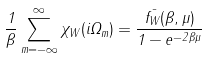Convert formula to latex. <formula><loc_0><loc_0><loc_500><loc_500>\frac { 1 } { \beta } \sum _ { m = - \infty } ^ { \infty } \chi _ { W } ( i \Omega _ { m } ) = \frac { \bar { f _ { W } } ( \beta , \mu ) } { 1 - e ^ { - 2 \beta \mu } }</formula> 